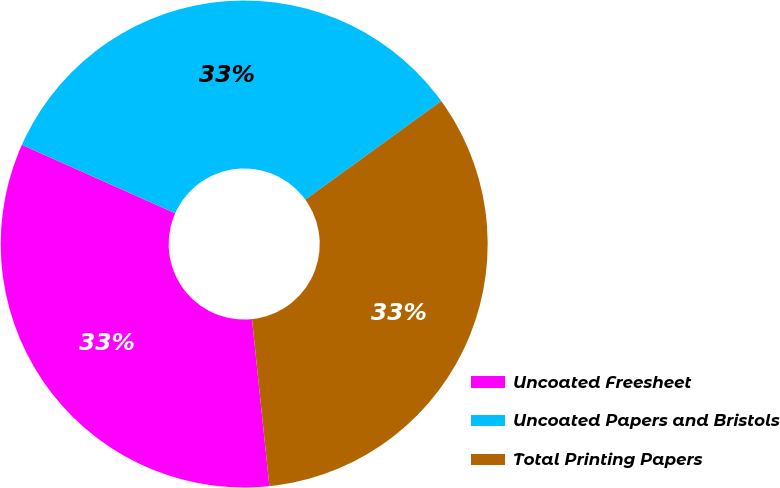Convert chart to OTSL. <chart><loc_0><loc_0><loc_500><loc_500><pie_chart><fcel>Uncoated Freesheet<fcel>Uncoated Papers and Bristols<fcel>Total Printing Papers<nl><fcel>33.33%<fcel>33.33%<fcel>33.34%<nl></chart> 